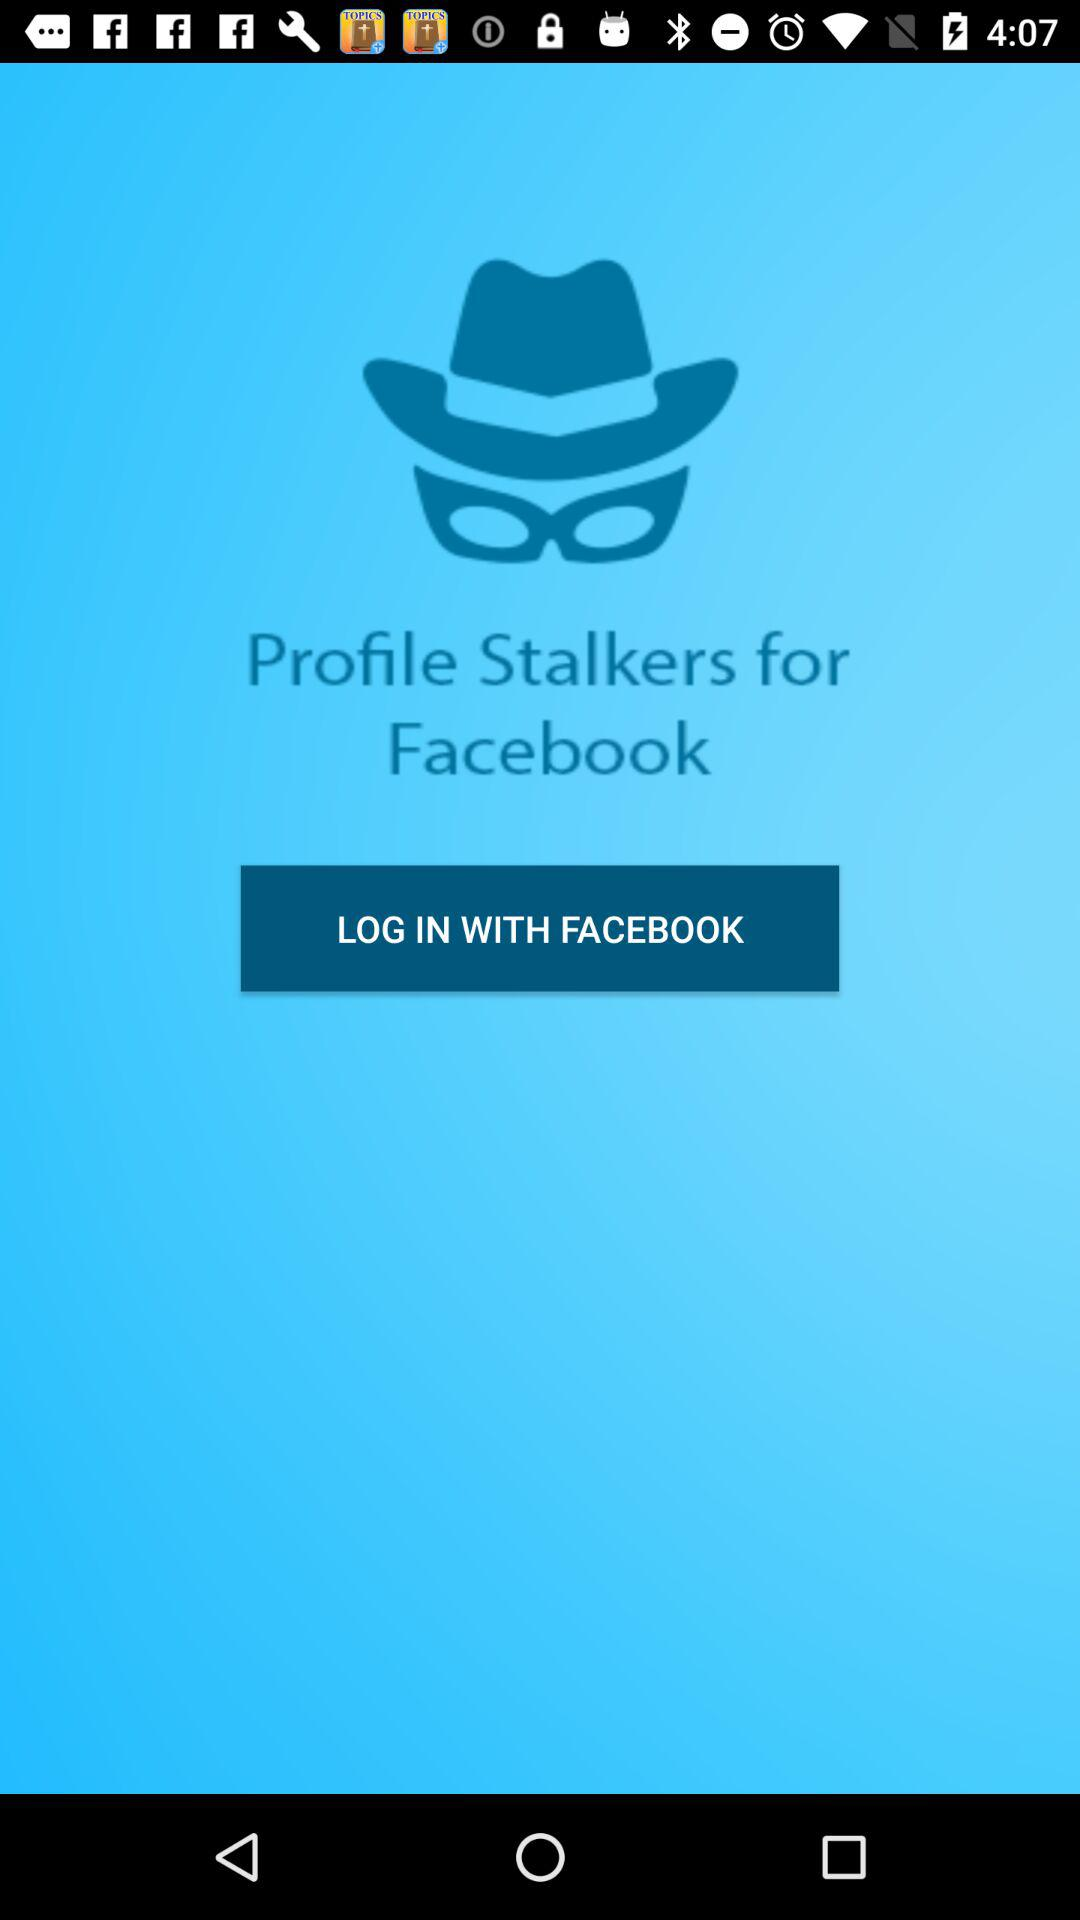Through what application can we log in? We can log in with Facebook. 